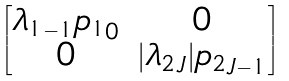<formula> <loc_0><loc_0><loc_500><loc_500>\begin{bmatrix} { \lambda _ { 1 } } _ { - 1 } { p _ { 1 } } _ { 0 } & 0 \\ 0 & | { \lambda _ { 2 } } _ { J } | { p _ { 2 } } _ { J - 1 } \end{bmatrix}</formula> 